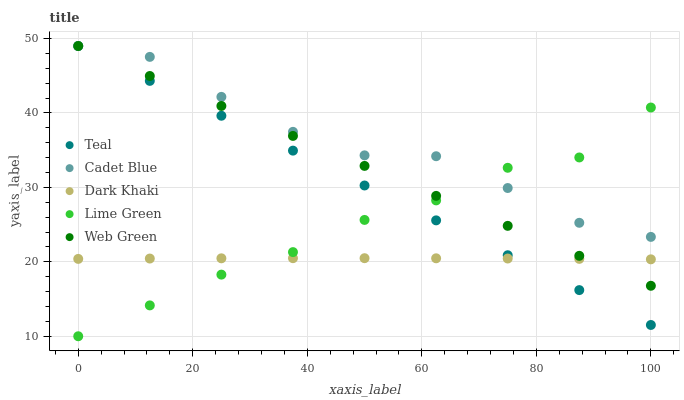Does Dark Khaki have the minimum area under the curve?
Answer yes or no. Yes. Does Cadet Blue have the maximum area under the curve?
Answer yes or no. Yes. Does Lime Green have the minimum area under the curve?
Answer yes or no. No. Does Lime Green have the maximum area under the curve?
Answer yes or no. No. Is Teal the smoothest?
Answer yes or no. Yes. Is Cadet Blue the roughest?
Answer yes or no. Yes. Is Lime Green the smoothest?
Answer yes or no. No. Is Lime Green the roughest?
Answer yes or no. No. Does Lime Green have the lowest value?
Answer yes or no. Yes. Does Cadet Blue have the lowest value?
Answer yes or no. No. Does Teal have the highest value?
Answer yes or no. Yes. Does Lime Green have the highest value?
Answer yes or no. No. Is Dark Khaki less than Cadet Blue?
Answer yes or no. Yes. Is Cadet Blue greater than Dark Khaki?
Answer yes or no. Yes. Does Web Green intersect Cadet Blue?
Answer yes or no. Yes. Is Web Green less than Cadet Blue?
Answer yes or no. No. Is Web Green greater than Cadet Blue?
Answer yes or no. No. Does Dark Khaki intersect Cadet Blue?
Answer yes or no. No. 